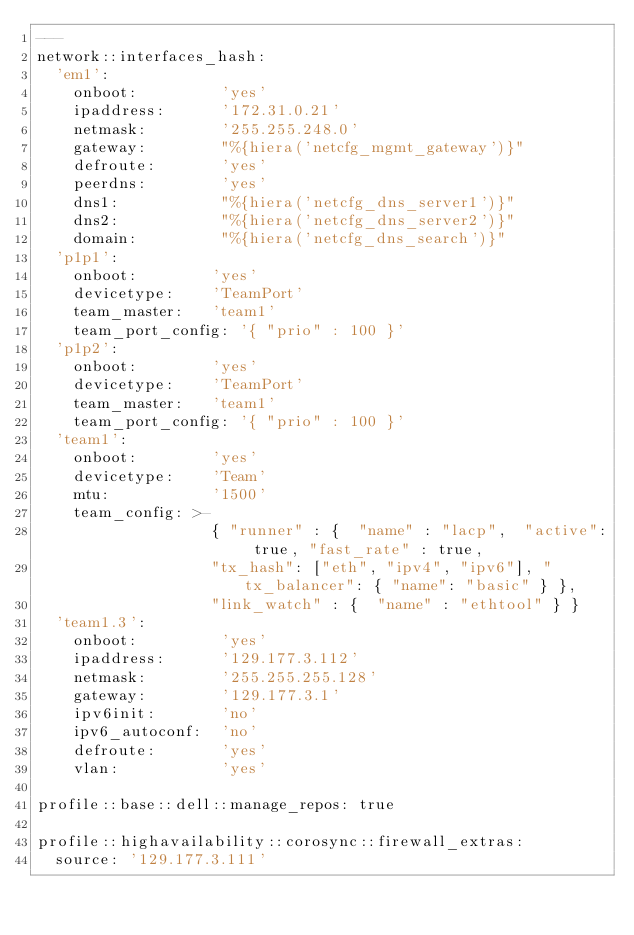Convert code to text. <code><loc_0><loc_0><loc_500><loc_500><_YAML_>---
network::interfaces_hash:
  'em1':
    onboot:         'yes'
    ipaddress:      '172.31.0.21'
    netmask:        '255.255.248.0'
    gateway:        "%{hiera('netcfg_mgmt_gateway')}"
    defroute:       'yes'
    peerdns:        'yes'
    dns1:           "%{hiera('netcfg_dns_server1')}"
    dns2:           "%{hiera('netcfg_dns_server2')}"
    domain:         "%{hiera('netcfg_dns_search')}"
  'p1p1':
    onboot:        'yes'
    devicetype:    'TeamPort'
    team_master:   'team1'
    team_port_config: '{ "prio" : 100 }'
  'p1p2':
    onboot:        'yes'
    devicetype:    'TeamPort'
    team_master:   'team1'
    team_port_config: '{ "prio" : 100 }'
  'team1':
    onboot:        'yes'
    devicetype:    'Team'
    mtu:           '1500'
    team_config: >-
                   { "runner" : {  "name" : "lacp",  "active": true, "fast_rate" : true,
                   "tx_hash": ["eth", "ipv4", "ipv6"], "tx_balancer": { "name": "basic" } },
                   "link_watch" : {  "name" : "ethtool" } }
  'team1.3':
    onboot:         'yes'
    ipaddress:      '129.177.3.112'
    netmask:        '255.255.255.128'
    gateway:        '129.177.3.1'
    ipv6init:       'no'
    ipv6_autoconf:  'no'
    defroute:       'yes'
    vlan:           'yes'

profile::base::dell::manage_repos: true

profile::highavailability::corosync::firewall_extras:
  source: '129.177.3.111'
</code> 